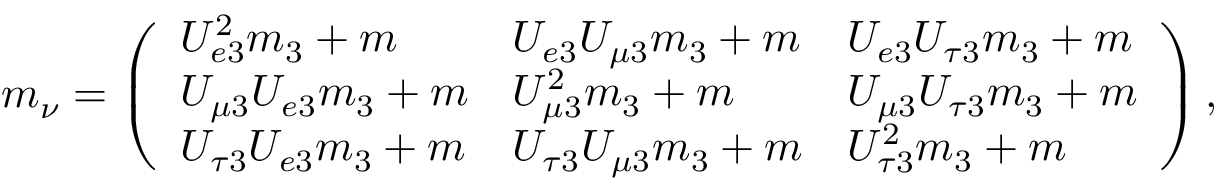<formula> <loc_0><loc_0><loc_500><loc_500>m _ { \nu } = \left ( \begin{array} { l l l } { { U _ { e 3 } ^ { 2 } m _ { 3 } + m } } & { { U _ { e 3 } U _ { \mu 3 } m _ { 3 } + m } } & { { U _ { e 3 } U _ { \tau 3 } m _ { 3 } + m } } \\ { { U _ { \mu 3 } U _ { e 3 } m _ { 3 } + m } } & { { U _ { \mu 3 } ^ { 2 } m _ { 3 } + m } } & { { U _ { \mu 3 } U _ { \tau 3 } m _ { 3 } + m } } \\ { { U _ { \tau 3 } U _ { e 3 } m _ { 3 } + m } } & { { U _ { \tau 3 } U _ { \mu 3 } m _ { 3 } + m } } & { { U _ { \tau 3 } ^ { 2 } m _ { 3 } + m } } \end{array} \right ) ,</formula> 